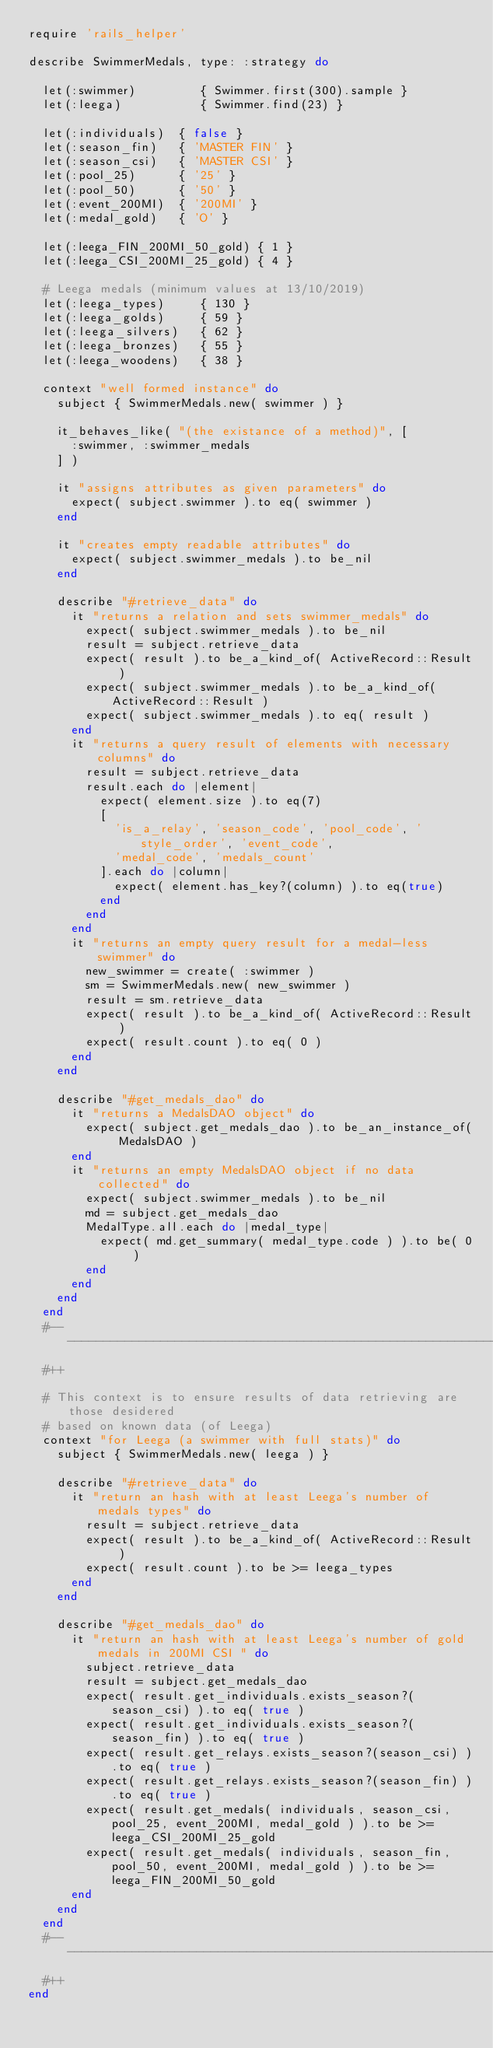Convert code to text. <code><loc_0><loc_0><loc_500><loc_500><_Ruby_>require 'rails_helper'

describe SwimmerMedals, type: :strategy do

  let(:swimmer)         { Swimmer.first(300).sample }
  let(:leega)           { Swimmer.find(23) }

  let(:individuals)  { false }
  let(:season_fin)   { 'MASTER FIN' }
  let(:season_csi)   { 'MASTER CSI' }
  let(:pool_25)      { '25' }
  let(:pool_50)      { '50' }
  let(:event_200MI)  { '200MI' }
  let(:medal_gold)   { 'O' }

  let(:leega_FIN_200MI_50_gold) { 1 }
  let(:leega_CSI_200MI_25_gold) { 4 }

  # Leega medals (minimum values at 13/10/2019)
  let(:leega_types)     { 130 }
  let(:leega_golds)     { 59 }
  let(:leega_silvers)   { 62 }
  let(:leega_bronzes)   { 55 }
  let(:leega_woodens)   { 38 }

  context "well formed instance" do
    subject { SwimmerMedals.new( swimmer ) }

    it_behaves_like( "(the existance of a method)", [
      :swimmer, :swimmer_medals
    ] )

    it "assigns attributes as given parameters" do
      expect( subject.swimmer ).to eq( swimmer )
    end

    it "creates empty readable attributes" do
      expect( subject.swimmer_medals ).to be_nil
    end

    describe "#retrieve_data" do
      it "returns a relation and sets swimmer_medals" do
        expect( subject.swimmer_medals ).to be_nil
        result = subject.retrieve_data
        expect( result ).to be_a_kind_of( ActiveRecord::Result )
        expect( subject.swimmer_medals ).to be_a_kind_of( ActiveRecord::Result )
        expect( subject.swimmer_medals ).to eq( result )
      end
      it "returns a query result of elements with necessary columns" do
        result = subject.retrieve_data
        result.each do |element|
          expect( element.size ).to eq(7)
          [
            'is_a_relay', 'season_code', 'pool_code', 'style_order', 'event_code',
            'medal_code', 'medals_count'
          ].each do |column|
            expect( element.has_key?(column) ).to eq(true)
          end
        end
      end
      it "returns an empty query result for a medal-less swimmer" do
        new_swimmer = create( :swimmer )
        sm = SwimmerMedals.new( new_swimmer )
        result = sm.retrieve_data
        expect( result ).to be_a_kind_of( ActiveRecord::Result )
        expect( result.count ).to eq( 0 )
      end
    end

    describe "#get_medals_dao" do
      it "returns a MedalsDAO object" do
        expect( subject.get_medals_dao ).to be_an_instance_of( MedalsDAO )
      end
      it "returns an empty MedalsDAO object if no data collected" do
        expect( subject.swimmer_medals ).to be_nil
        md = subject.get_medals_dao
        MedalType.all.each do |medal_type|
          expect( md.get_summary( medal_type.code ) ).to be( 0 )
        end
      end
    end
  end
  #-- -------------------------------------------------------------------------
  #++

  # This context is to ensure results of data retrieving are those desidered
  # based on known data (of Leega)
  context "for Leega (a swimmer with full stats)" do
    subject { SwimmerMedals.new( leega ) }

    describe "#retrieve_data" do
      it "return an hash with at least Leega's number of medals types" do
        result = subject.retrieve_data
        expect( result ).to be_a_kind_of( ActiveRecord::Result )
        expect( result.count ).to be >= leega_types
      end
    end

    describe "#get_medals_dao" do
      it "return an hash with at least Leega's number of gold medals in 200MI CSI " do
        subject.retrieve_data
        result = subject.get_medals_dao
        expect( result.get_individuals.exists_season?(season_csi) ).to eq( true )
        expect( result.get_individuals.exists_season?(season_fin) ).to eq( true )
        expect( result.get_relays.exists_season?(season_csi) ).to eq( true )
        expect( result.get_relays.exists_season?(season_fin) ).to eq( true )
        expect( result.get_medals( individuals, season_csi, pool_25, event_200MI, medal_gold ) ).to be >= leega_CSI_200MI_25_gold
        expect( result.get_medals( individuals, season_fin, pool_50, event_200MI, medal_gold ) ).to be >= leega_FIN_200MI_50_gold
      end
    end
  end
  #-- -------------------------------------------------------------------------
  #++
end
</code> 